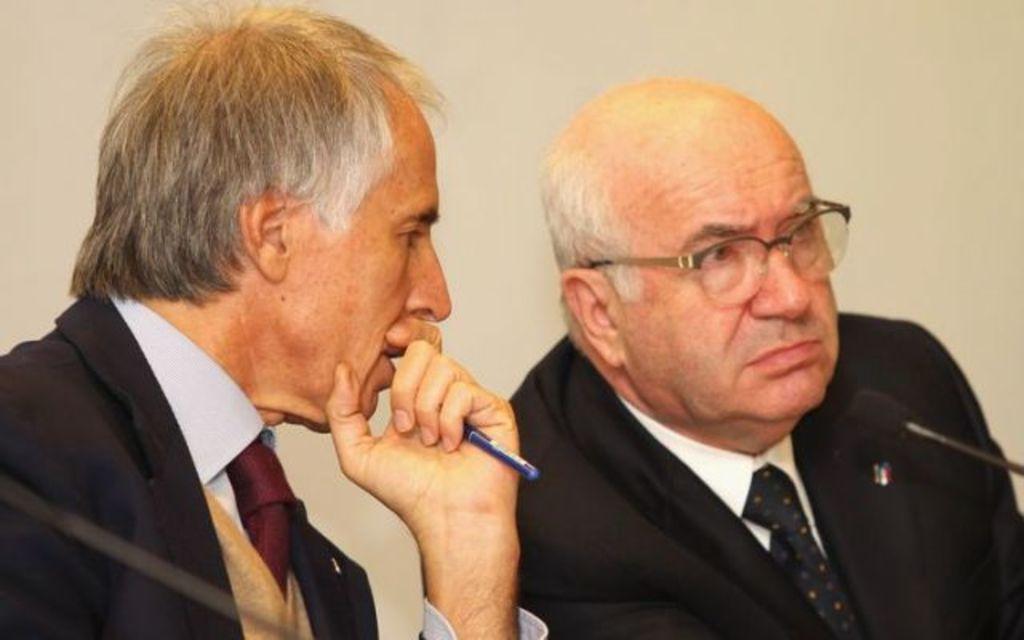Can you describe this image briefly? On the left side, there is a person in a suit, holding a pen with a hand, sitting and speaking. On the right side, there is another person in a suit, wearing a spectacle, watching something and sitting in front of a microphone. And the background is white in color. 